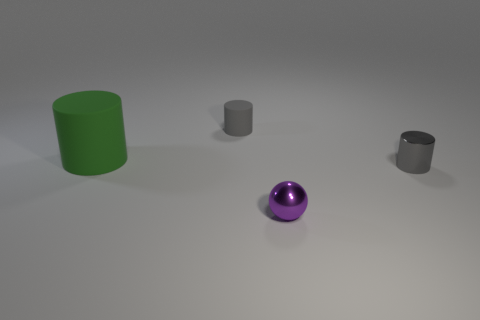Is there anything else that has the same size as the green matte cylinder?
Your response must be concise. No. What number of things are rubber things that are behind the big rubber thing or tiny shiny cylinders?
Provide a succinct answer. 2. Is there another matte object that has the same shape as the purple object?
Ensure brevity in your answer.  No. There is a gray thing that is in front of the big object to the left of the purple thing; what is its shape?
Offer a terse response. Cylinder. What number of blocks are either large rubber objects or purple objects?
Your answer should be very brief. 0. There is a small cylinder that is the same color as the small rubber thing; what material is it?
Keep it short and to the point. Metal. There is a thing that is behind the green object; is its shape the same as the matte thing in front of the gray rubber cylinder?
Offer a terse response. Yes. The cylinder that is both left of the small gray metallic thing and to the right of the large cylinder is what color?
Your response must be concise. Gray. Does the tiny shiny cylinder have the same color as the cylinder that is behind the green matte cylinder?
Your answer should be compact. Yes. What size is the thing that is both left of the small purple shiny thing and in front of the gray rubber object?
Your answer should be compact. Large. 